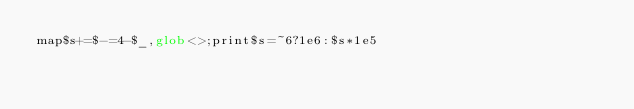<code> <loc_0><loc_0><loc_500><loc_500><_Perl_>map$s+=$-=4-$_,glob<>;print$s=~6?1e6:$s*1e5</code> 